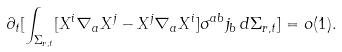Convert formula to latex. <formula><loc_0><loc_0><loc_500><loc_500>\partial _ { t } [ \int _ { \Sigma _ { r , t } } [ X ^ { i } \nabla _ { a } X ^ { j } - X ^ { j } \nabla _ { a } X ^ { i } ] \sigma ^ { a b } j _ { b } \, d \Sigma _ { r , t } ] = o ( 1 ) .</formula> 